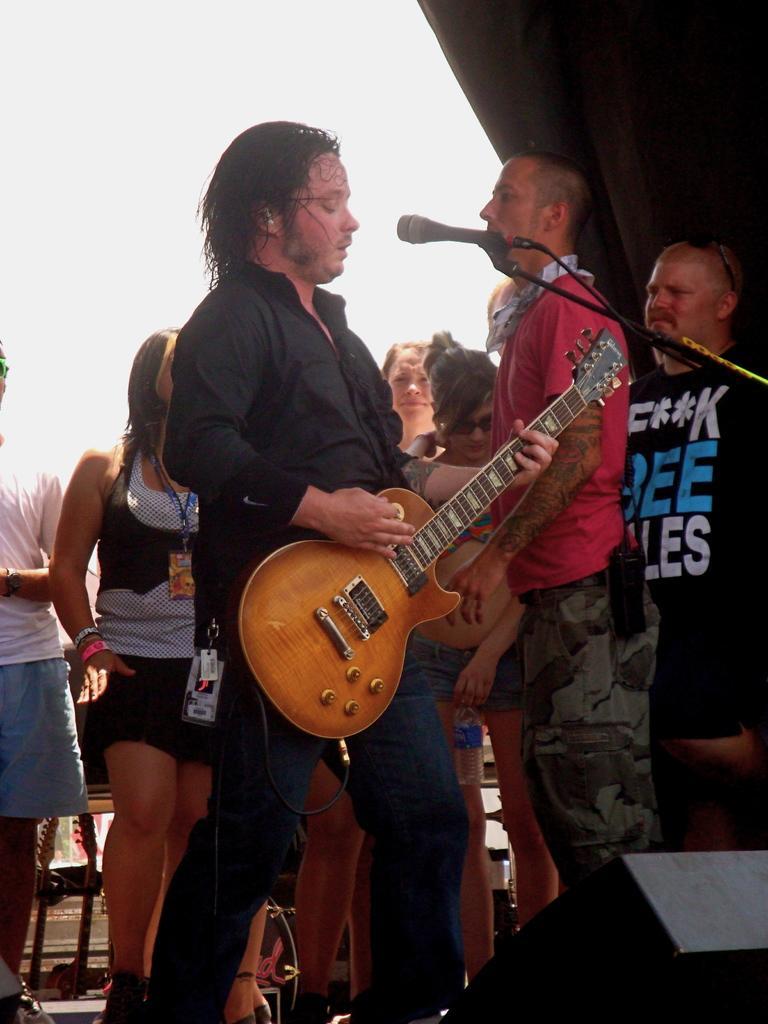Could you give a brief overview of what you see in this image? In the image we can see there is a person who is standing and holding guitar in his hand. Behind there are lot of people who are standing and they are wearing id cards in their neck. 